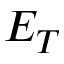Convert formula to latex. <formula><loc_0><loc_0><loc_500><loc_500>E _ { T }</formula> 